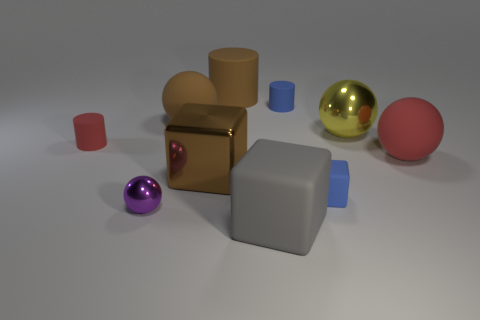There is a large brown object that is the same shape as the big gray object; what is its material?
Offer a very short reply. Metal. What is the color of the small matte cube?
Your response must be concise. Blue. What number of objects are either cubes or red things?
Your answer should be very brief. 5. There is a red object left of the matte thing in front of the purple shiny thing; what shape is it?
Your answer should be compact. Cylinder. How many other things are there of the same material as the big cylinder?
Your answer should be compact. 6. Is the small purple ball made of the same material as the big cube behind the blue cube?
Offer a terse response. Yes. What number of things are tiny matte cylinders that are on the right side of the small ball or spheres left of the big gray matte block?
Offer a very short reply. 3. How many other objects are the same color as the big cylinder?
Your response must be concise. 2. Is the number of tiny objects that are left of the brown metallic thing greater than the number of red objects that are right of the yellow metal sphere?
Your answer should be very brief. Yes. What number of balls are cyan things or small purple objects?
Your answer should be very brief. 1. 